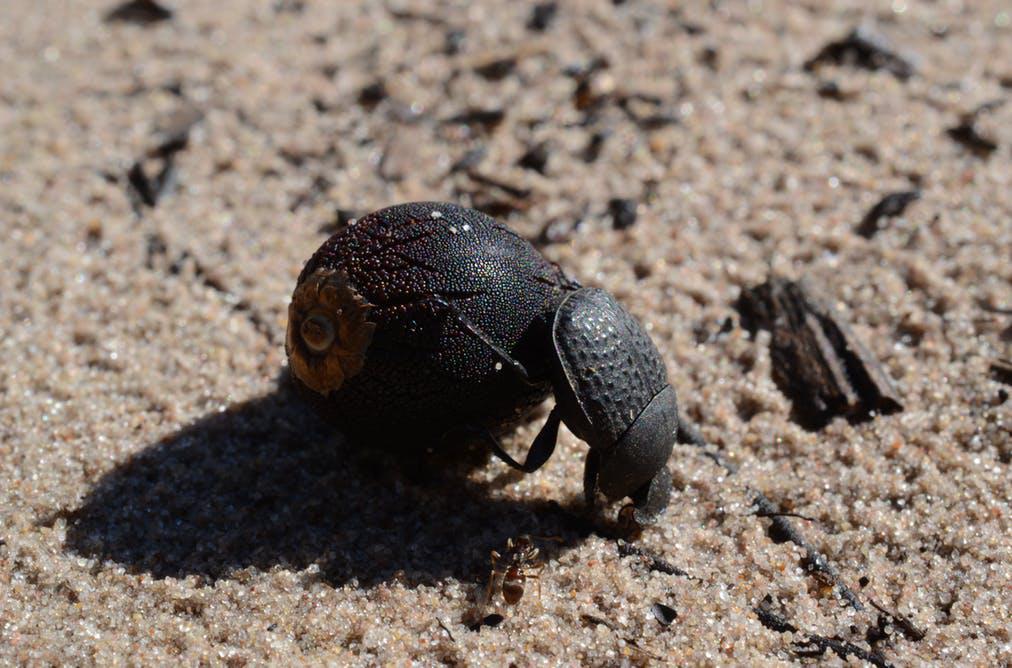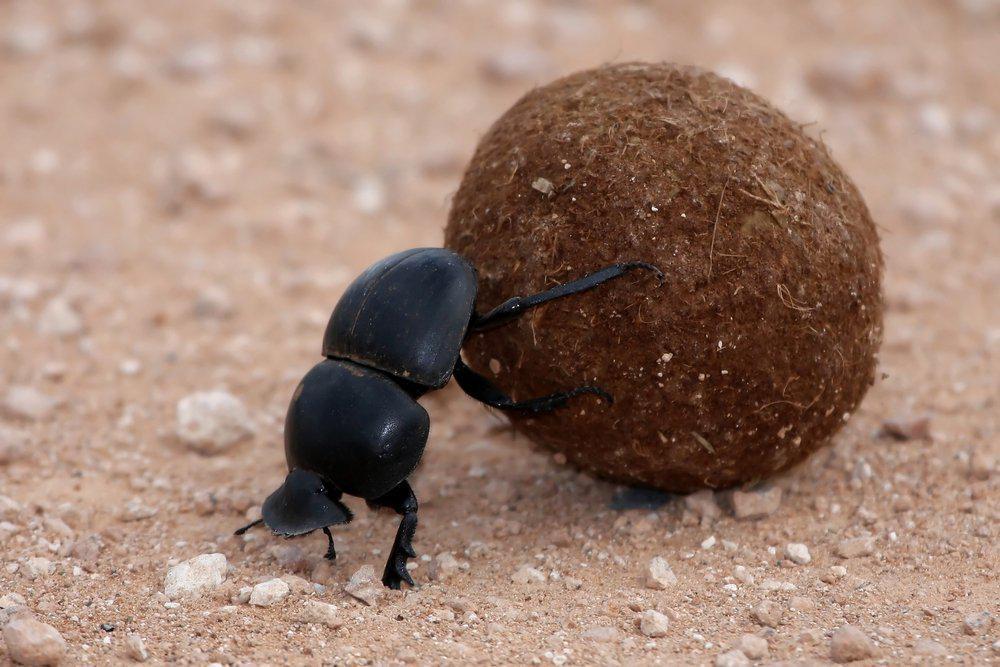The first image is the image on the left, the second image is the image on the right. Evaluate the accuracy of this statement regarding the images: "Every image has a single beetle and a single dungball.". Is it true? Answer yes or no. Yes. The first image is the image on the left, the second image is the image on the right. Analyze the images presented: Is the assertion "One image contains two beetles and a single brown ball." valid? Answer yes or no. No. 